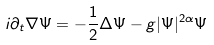<formula> <loc_0><loc_0><loc_500><loc_500>i \partial _ { t } \nabla \Psi = - \frac { 1 } { 2 } \Delta \Psi - g | \Psi | ^ { 2 \alpha } \Psi</formula> 